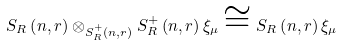Convert formula to latex. <formula><loc_0><loc_0><loc_500><loc_500>S _ { R } \left ( n , r \right ) \otimes _ { S ^ { + } _ { R } \left ( n , r \right ) } S ^ { + } _ { R } \left ( n , r \right ) \xi _ { \mu } \cong S _ { R } \left ( n , r \right ) \xi _ { \mu }</formula> 